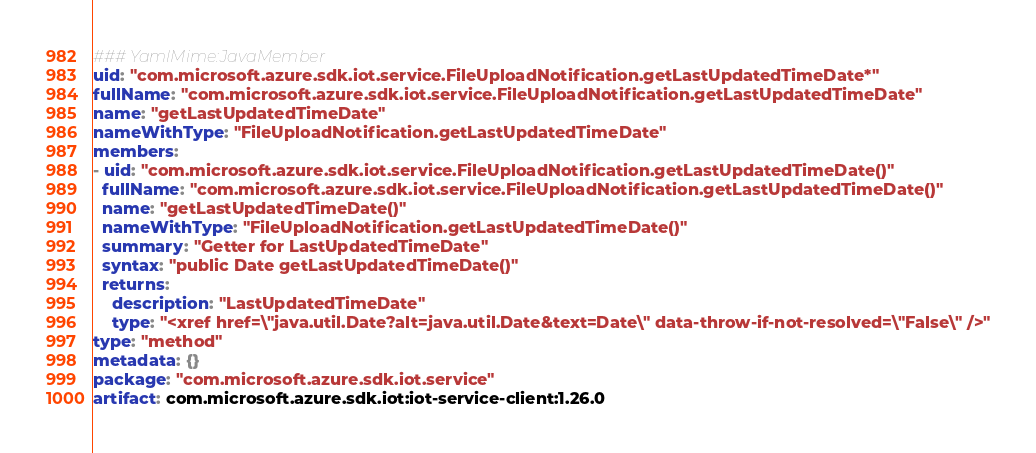Convert code to text. <code><loc_0><loc_0><loc_500><loc_500><_YAML_>### YamlMime:JavaMember
uid: "com.microsoft.azure.sdk.iot.service.FileUploadNotification.getLastUpdatedTimeDate*"
fullName: "com.microsoft.azure.sdk.iot.service.FileUploadNotification.getLastUpdatedTimeDate"
name: "getLastUpdatedTimeDate"
nameWithType: "FileUploadNotification.getLastUpdatedTimeDate"
members:
- uid: "com.microsoft.azure.sdk.iot.service.FileUploadNotification.getLastUpdatedTimeDate()"
  fullName: "com.microsoft.azure.sdk.iot.service.FileUploadNotification.getLastUpdatedTimeDate()"
  name: "getLastUpdatedTimeDate()"
  nameWithType: "FileUploadNotification.getLastUpdatedTimeDate()"
  summary: "Getter for LastUpdatedTimeDate"
  syntax: "public Date getLastUpdatedTimeDate()"
  returns:
    description: "LastUpdatedTimeDate"
    type: "<xref href=\"java.util.Date?alt=java.util.Date&text=Date\" data-throw-if-not-resolved=\"False\" />"
type: "method"
metadata: {}
package: "com.microsoft.azure.sdk.iot.service"
artifact: com.microsoft.azure.sdk.iot:iot-service-client:1.26.0
</code> 